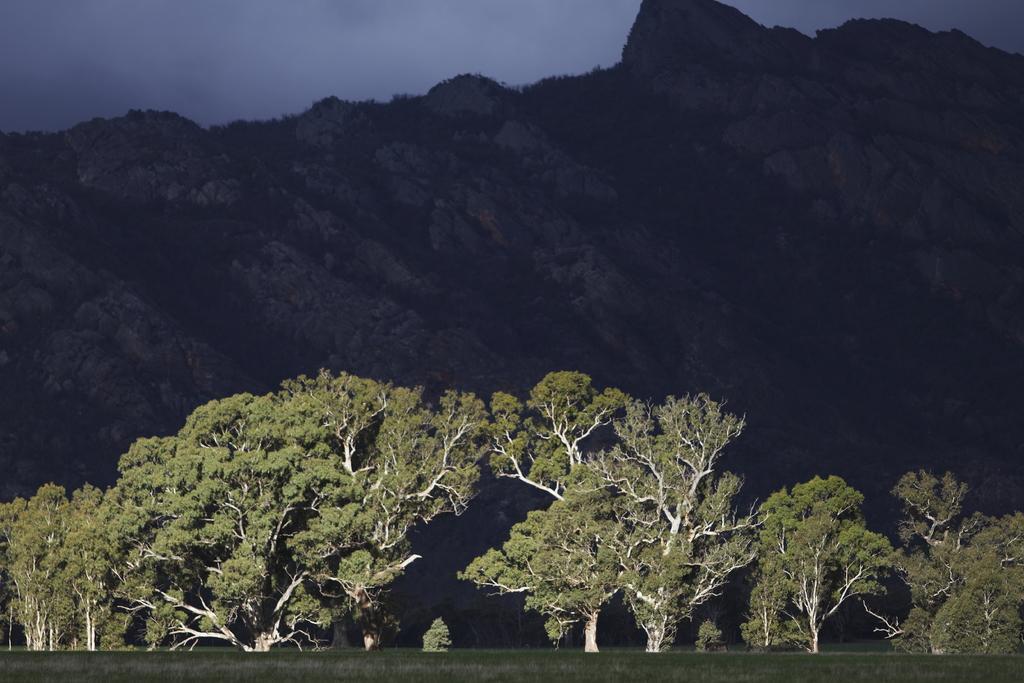Can you describe this image briefly? In this image in the front there are trees. In the background there are mountains and the sky is cloudy. 